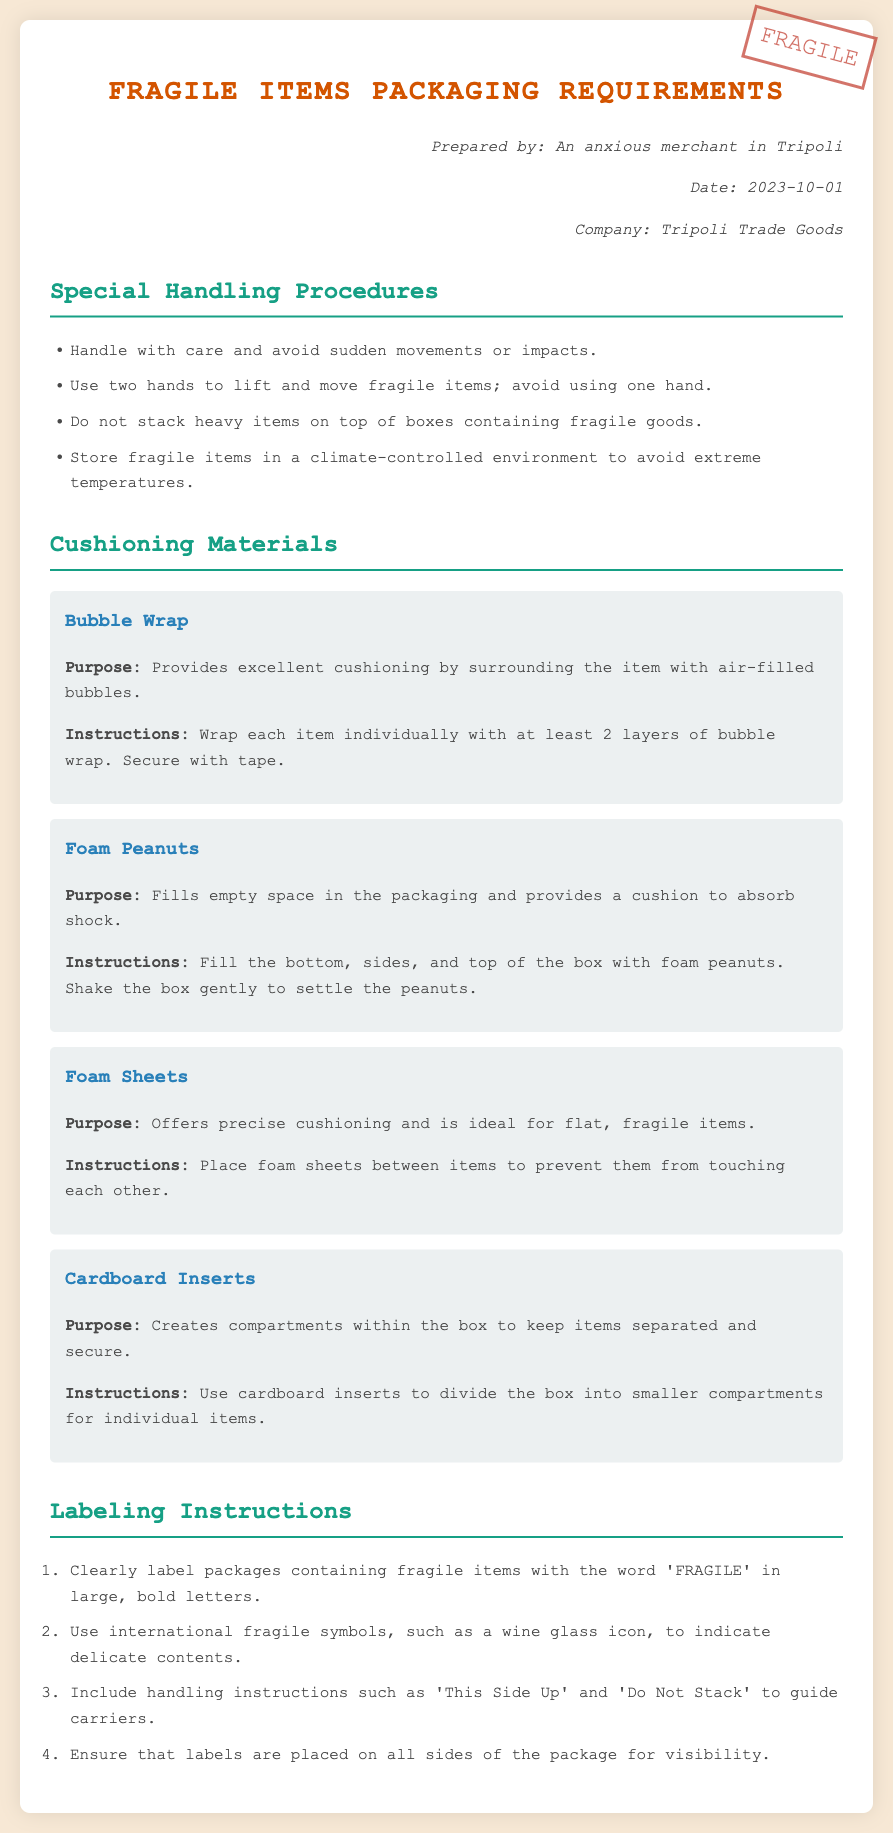what is the title of the document? The title of the document is prominently displayed as "Fragile Items Packaging Requirements."
Answer: Fragile Items Packaging Requirements who prepared the document? The header information includes the name of the person who prepared the document, which is "An anxious merchant in Tripoli."
Answer: An anxious merchant in Tripoli what is the date of preparation? The document contains a date under the header information indicating when it was prepared, which is "2023-10-01."
Answer: 2023-10-01 how many cushioning materials are listed? The document includes four types of cushioning materials specified in separate sections.
Answer: 4 what handling instruction is provided for lifting fragile items? The document specifies to "Use two hands to lift and move fragile items."
Answer: Use two hands to lift and move fragile items what specific label should be used for fragile items? The document instructs to label packages containing fragile items with the word 'FRAGILE' in large, bold letters.
Answer: 'FRAGILE' which cushioning material is ideal for flat items? The document mentions that "Foam Sheets" offer precise cushioning and are ideal for flat, fragile items.
Answer: Foam Sheets what should be included in the labeling instructions? The document states to include handling instructions like 'This Side Up' and 'Do Not Stack.'
Answer: 'This Side Up' and 'Do Not Stack' what is the purpose of cardboard inserts? According to the document, cardboard inserts "create compartments within the box to keep items separated and secure."
Answer: create compartments within the box to keep items separated and secure 